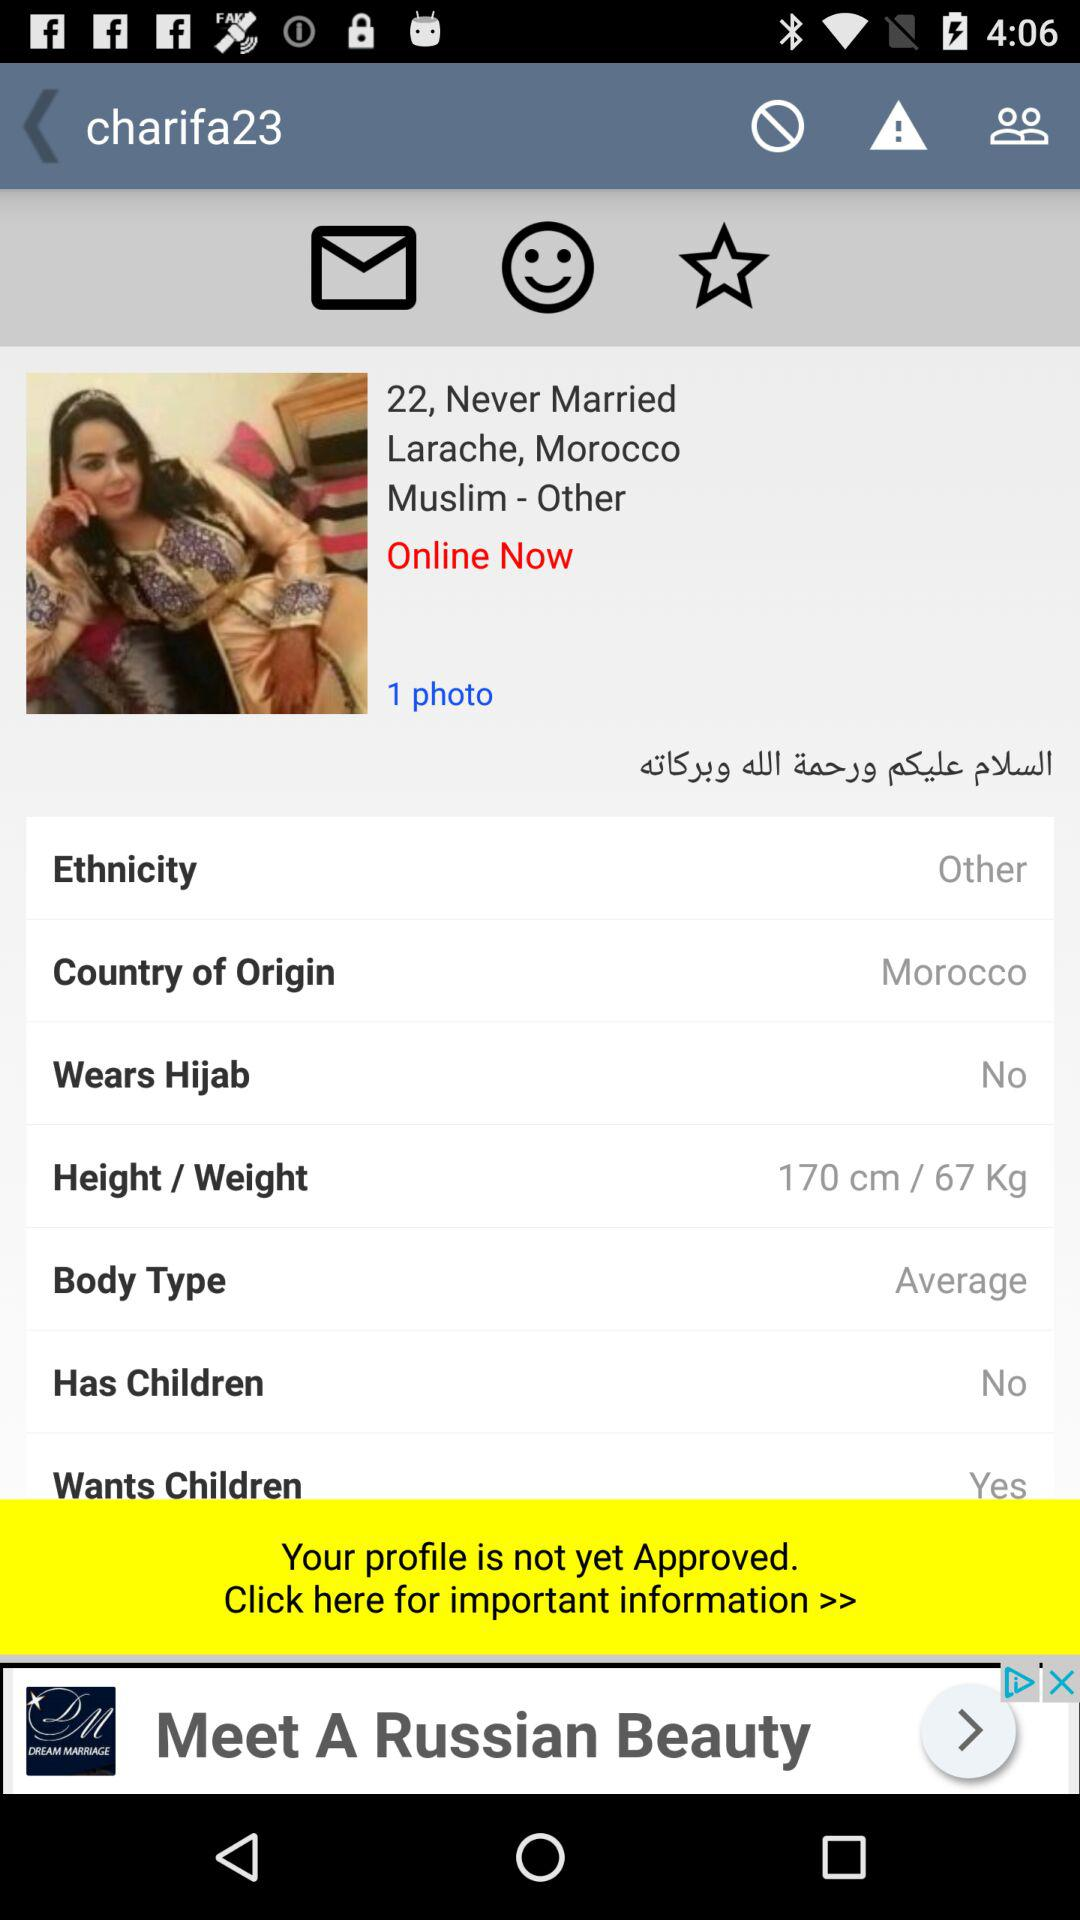What is the country of origin of the user? The country of origin of the user is Morocco. 